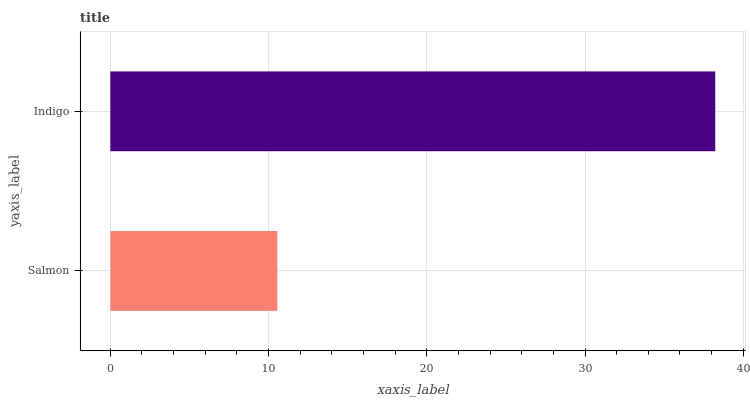Is Salmon the minimum?
Answer yes or no. Yes. Is Indigo the maximum?
Answer yes or no. Yes. Is Indigo the minimum?
Answer yes or no. No. Is Indigo greater than Salmon?
Answer yes or no. Yes. Is Salmon less than Indigo?
Answer yes or no. Yes. Is Salmon greater than Indigo?
Answer yes or no. No. Is Indigo less than Salmon?
Answer yes or no. No. Is Indigo the high median?
Answer yes or no. Yes. Is Salmon the low median?
Answer yes or no. Yes. Is Salmon the high median?
Answer yes or no. No. Is Indigo the low median?
Answer yes or no. No. 